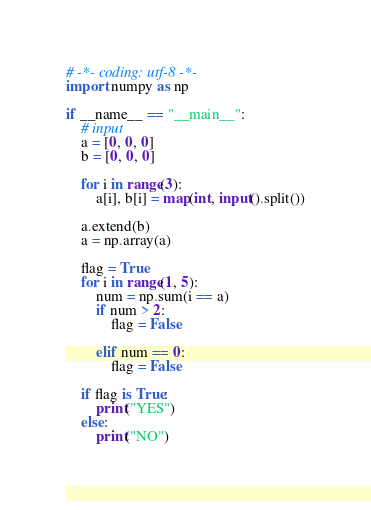<code> <loc_0><loc_0><loc_500><loc_500><_Python_># -*- coding: utf-8 -*-
import numpy as np

if __name__ == "__main__":
    # input
    a = [0, 0, 0]
    b = [0, 0, 0]

    for i in range(3):
        a[i], b[i] = map(int, input().split())

    a.extend(b)
    a = np.array(a)

    flag = True
    for i in range(1, 5):
        num = np.sum(i == a)
        if num > 2:
            flag = False

        elif num == 0:
            flag = False

    if flag is True:
        print("YES")
    else:
        print("NO")
</code> 